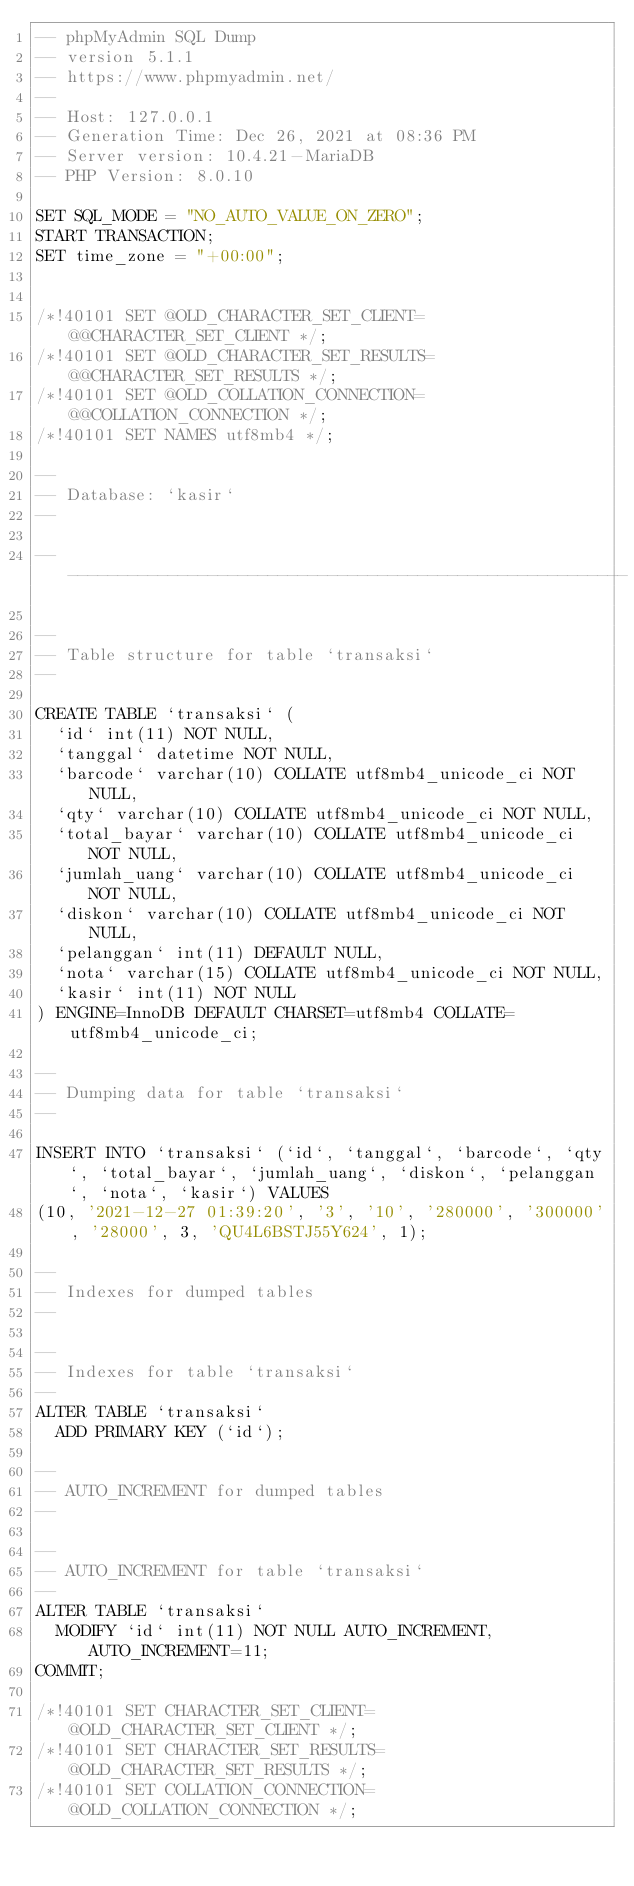<code> <loc_0><loc_0><loc_500><loc_500><_SQL_>-- phpMyAdmin SQL Dump
-- version 5.1.1
-- https://www.phpmyadmin.net/
--
-- Host: 127.0.0.1
-- Generation Time: Dec 26, 2021 at 08:36 PM
-- Server version: 10.4.21-MariaDB
-- PHP Version: 8.0.10

SET SQL_MODE = "NO_AUTO_VALUE_ON_ZERO";
START TRANSACTION;
SET time_zone = "+00:00";


/*!40101 SET @OLD_CHARACTER_SET_CLIENT=@@CHARACTER_SET_CLIENT */;
/*!40101 SET @OLD_CHARACTER_SET_RESULTS=@@CHARACTER_SET_RESULTS */;
/*!40101 SET @OLD_COLLATION_CONNECTION=@@COLLATION_CONNECTION */;
/*!40101 SET NAMES utf8mb4 */;

--
-- Database: `kasir`
--

-- --------------------------------------------------------

--
-- Table structure for table `transaksi`
--

CREATE TABLE `transaksi` (
  `id` int(11) NOT NULL,
  `tanggal` datetime NOT NULL,
  `barcode` varchar(10) COLLATE utf8mb4_unicode_ci NOT NULL,
  `qty` varchar(10) COLLATE utf8mb4_unicode_ci NOT NULL,
  `total_bayar` varchar(10) COLLATE utf8mb4_unicode_ci NOT NULL,
  `jumlah_uang` varchar(10) COLLATE utf8mb4_unicode_ci NOT NULL,
  `diskon` varchar(10) COLLATE utf8mb4_unicode_ci NOT NULL,
  `pelanggan` int(11) DEFAULT NULL,
  `nota` varchar(15) COLLATE utf8mb4_unicode_ci NOT NULL,
  `kasir` int(11) NOT NULL
) ENGINE=InnoDB DEFAULT CHARSET=utf8mb4 COLLATE=utf8mb4_unicode_ci;

--
-- Dumping data for table `transaksi`
--

INSERT INTO `transaksi` (`id`, `tanggal`, `barcode`, `qty`, `total_bayar`, `jumlah_uang`, `diskon`, `pelanggan`, `nota`, `kasir`) VALUES
(10, '2021-12-27 01:39:20', '3', '10', '280000', '300000', '28000', 3, 'QU4L6BSTJ55Y624', 1);

--
-- Indexes for dumped tables
--

--
-- Indexes for table `transaksi`
--
ALTER TABLE `transaksi`
  ADD PRIMARY KEY (`id`);

--
-- AUTO_INCREMENT for dumped tables
--

--
-- AUTO_INCREMENT for table `transaksi`
--
ALTER TABLE `transaksi`
  MODIFY `id` int(11) NOT NULL AUTO_INCREMENT, AUTO_INCREMENT=11;
COMMIT;

/*!40101 SET CHARACTER_SET_CLIENT=@OLD_CHARACTER_SET_CLIENT */;
/*!40101 SET CHARACTER_SET_RESULTS=@OLD_CHARACTER_SET_RESULTS */;
/*!40101 SET COLLATION_CONNECTION=@OLD_COLLATION_CONNECTION */;
</code> 